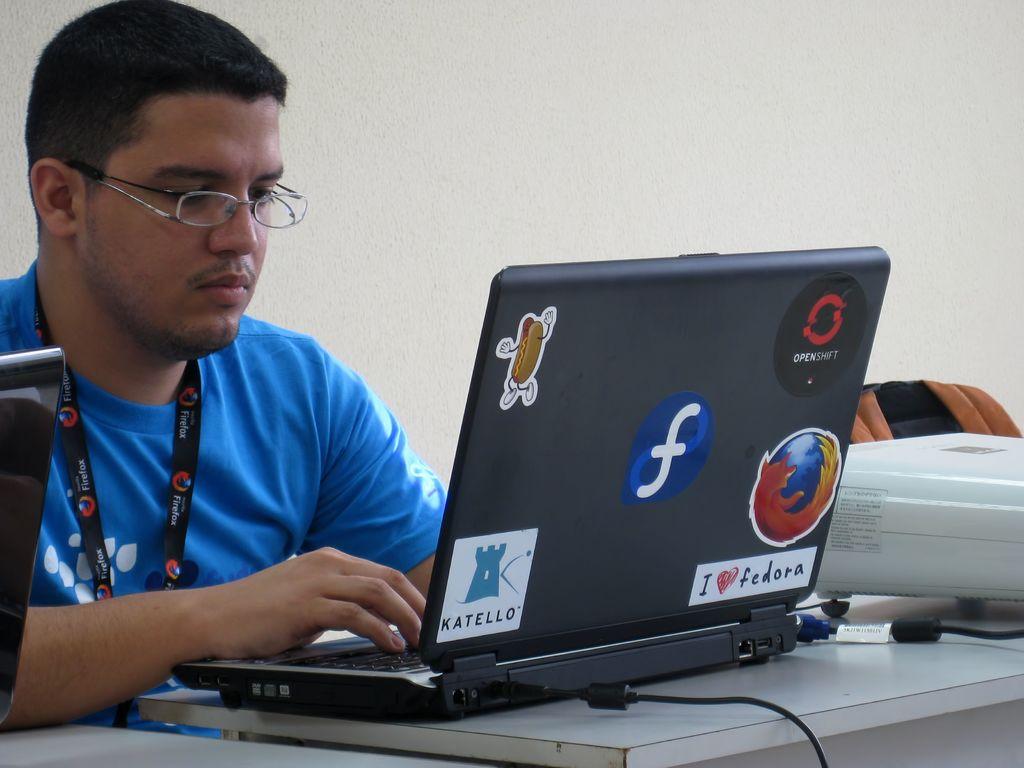What does the sticker with the heart say?
Provide a succinct answer. I love fedora. What browser name is written on the man's lanyard?
Keep it short and to the point. Firefox. 